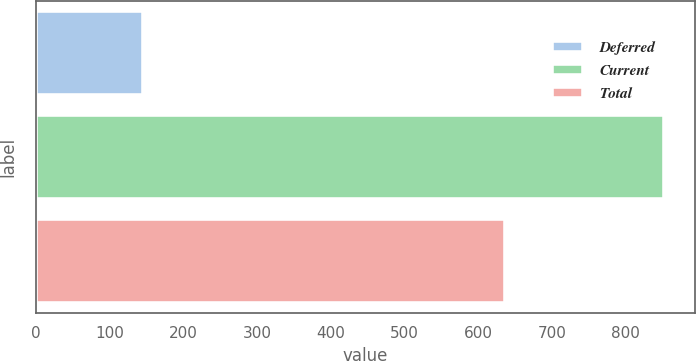Convert chart to OTSL. <chart><loc_0><loc_0><loc_500><loc_500><bar_chart><fcel>Deferred<fcel>Current<fcel>Total<nl><fcel>146<fcel>852<fcel>636<nl></chart> 